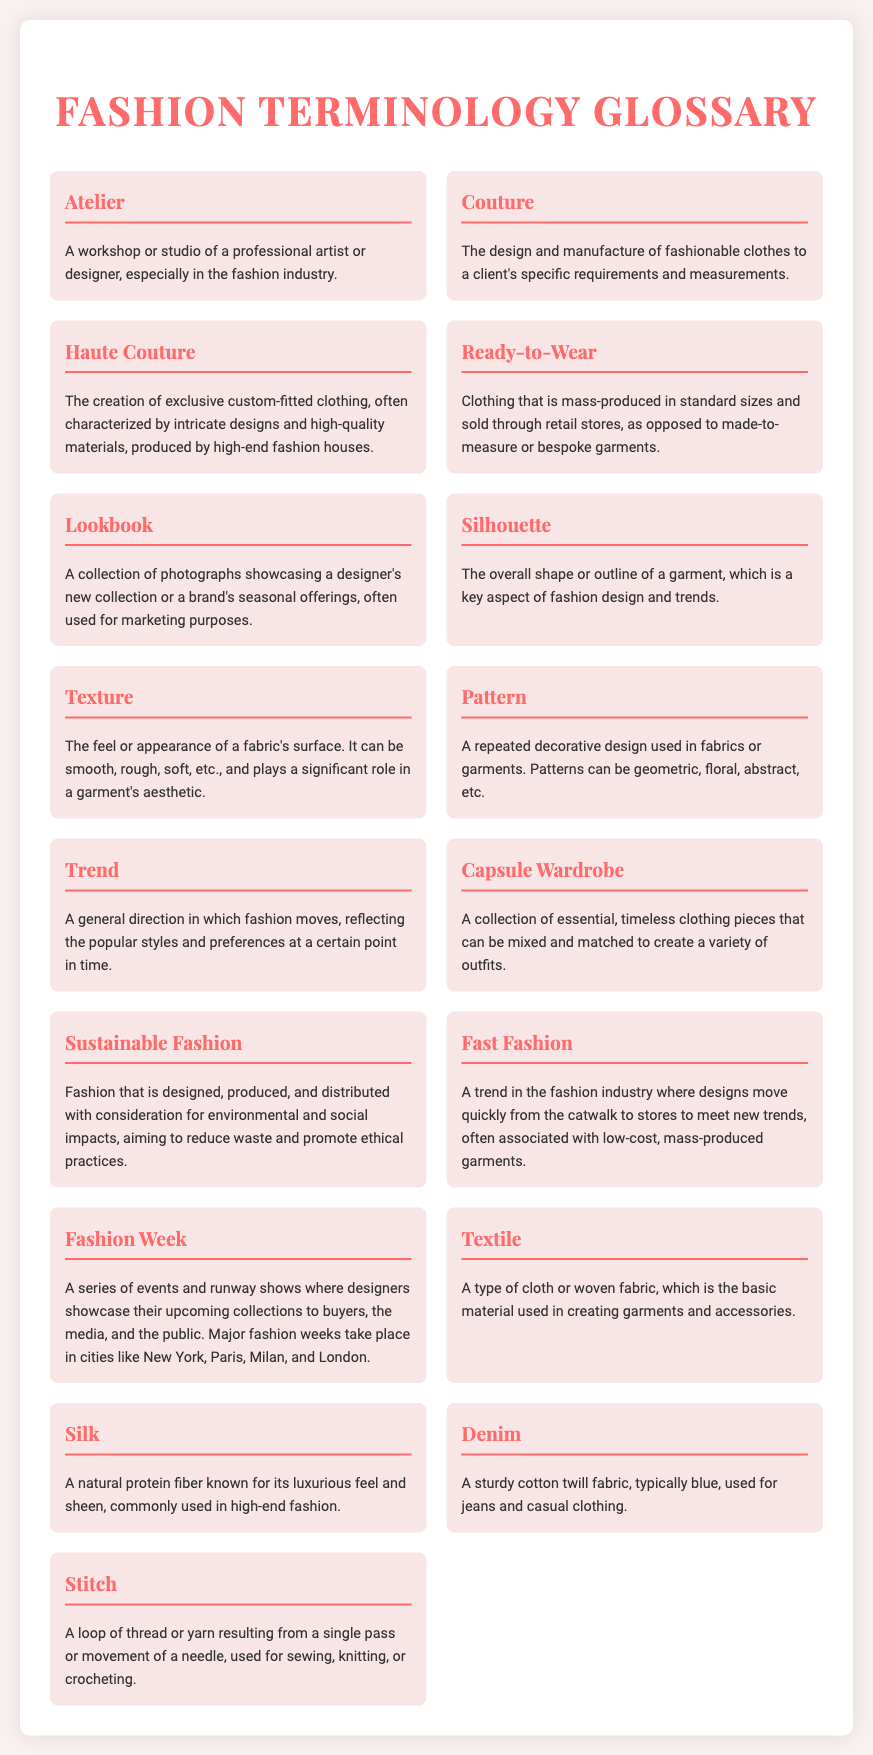What is an Atelier? An Atelier is defined in the document as a workshop or studio of a professional artist or designer, particularly in the fashion industry.
Answer: A workshop or studio What does Couture refer to? Couture is explained in the document as the design and manufacture of fashionable clothes to a client's specific requirements and measurements.
Answer: Design and manufacture of fashionable clothes What is Haute Couture characterized by? According to the document, Haute Couture is characterized by intricate designs and high-quality materials produced by high-end fashion houses.
Answer: Intricate designs and high-quality materials What does Ready-to-Wear mean? Ready-to-Wear is detailed in the document as clothing that is mass-produced in standard sizes and sold through retail stores.
Answer: Mass-produced clothing Which term describes a collection of essential clothing pieces? The term is Capsule Wardrobe, which is explained in the document as a collection of essential, timeless clothing pieces that can be mixed and matched.
Answer: Capsule Wardrobe What is Sustainable Fashion focused on? Sustainable Fashion is focused on being designed, produced, and distributed with consideration for environmental and social impacts.
Answer: Environmental and social impacts What does Fashion Week involve? Fashion Week involves a series of events and runway shows where designers showcase their upcoming collections.
Answer: A series of events and runway shows How many types of fabrics are mentioned in the glossary? The glossary mentions three types of fabrics: Silk, Denim, and Textile.
Answer: Three types What is a Lookbook used for? A Lookbook is used for showcasing a designer's new collection or a brand's seasonal offerings, as indicated in the document.
Answer: Showcasing new collections 